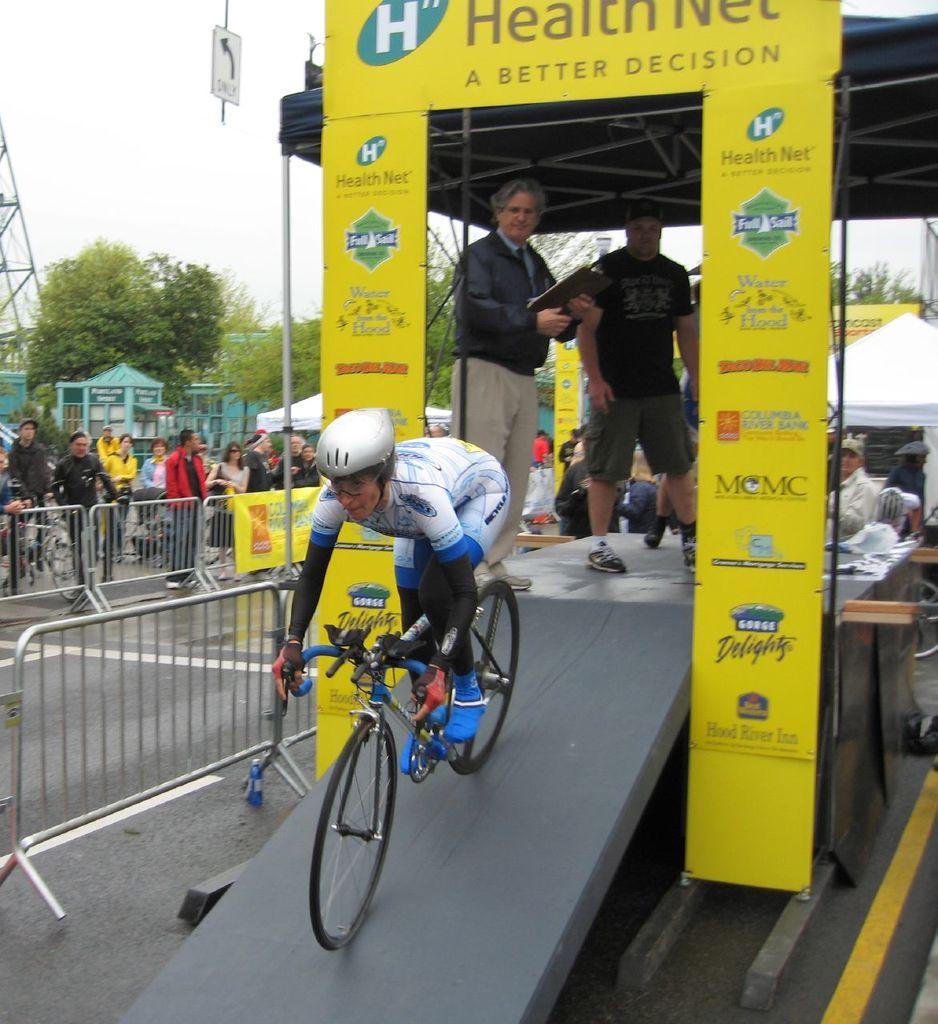Can you describe this image briefly? There is a group of people. They are standing. In the center of the person is riding a bicycle. He is wearing a helmet and back side of the person is holding a book. We can see in the background trees ,fence,banners ,sky,tent and stand. 